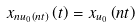<formula> <loc_0><loc_0><loc_500><loc_500>x _ { n u _ { 0 } \left ( n t \right ) } \left ( t \right ) = x _ { u _ { 0 } } \left ( n t \right )</formula> 